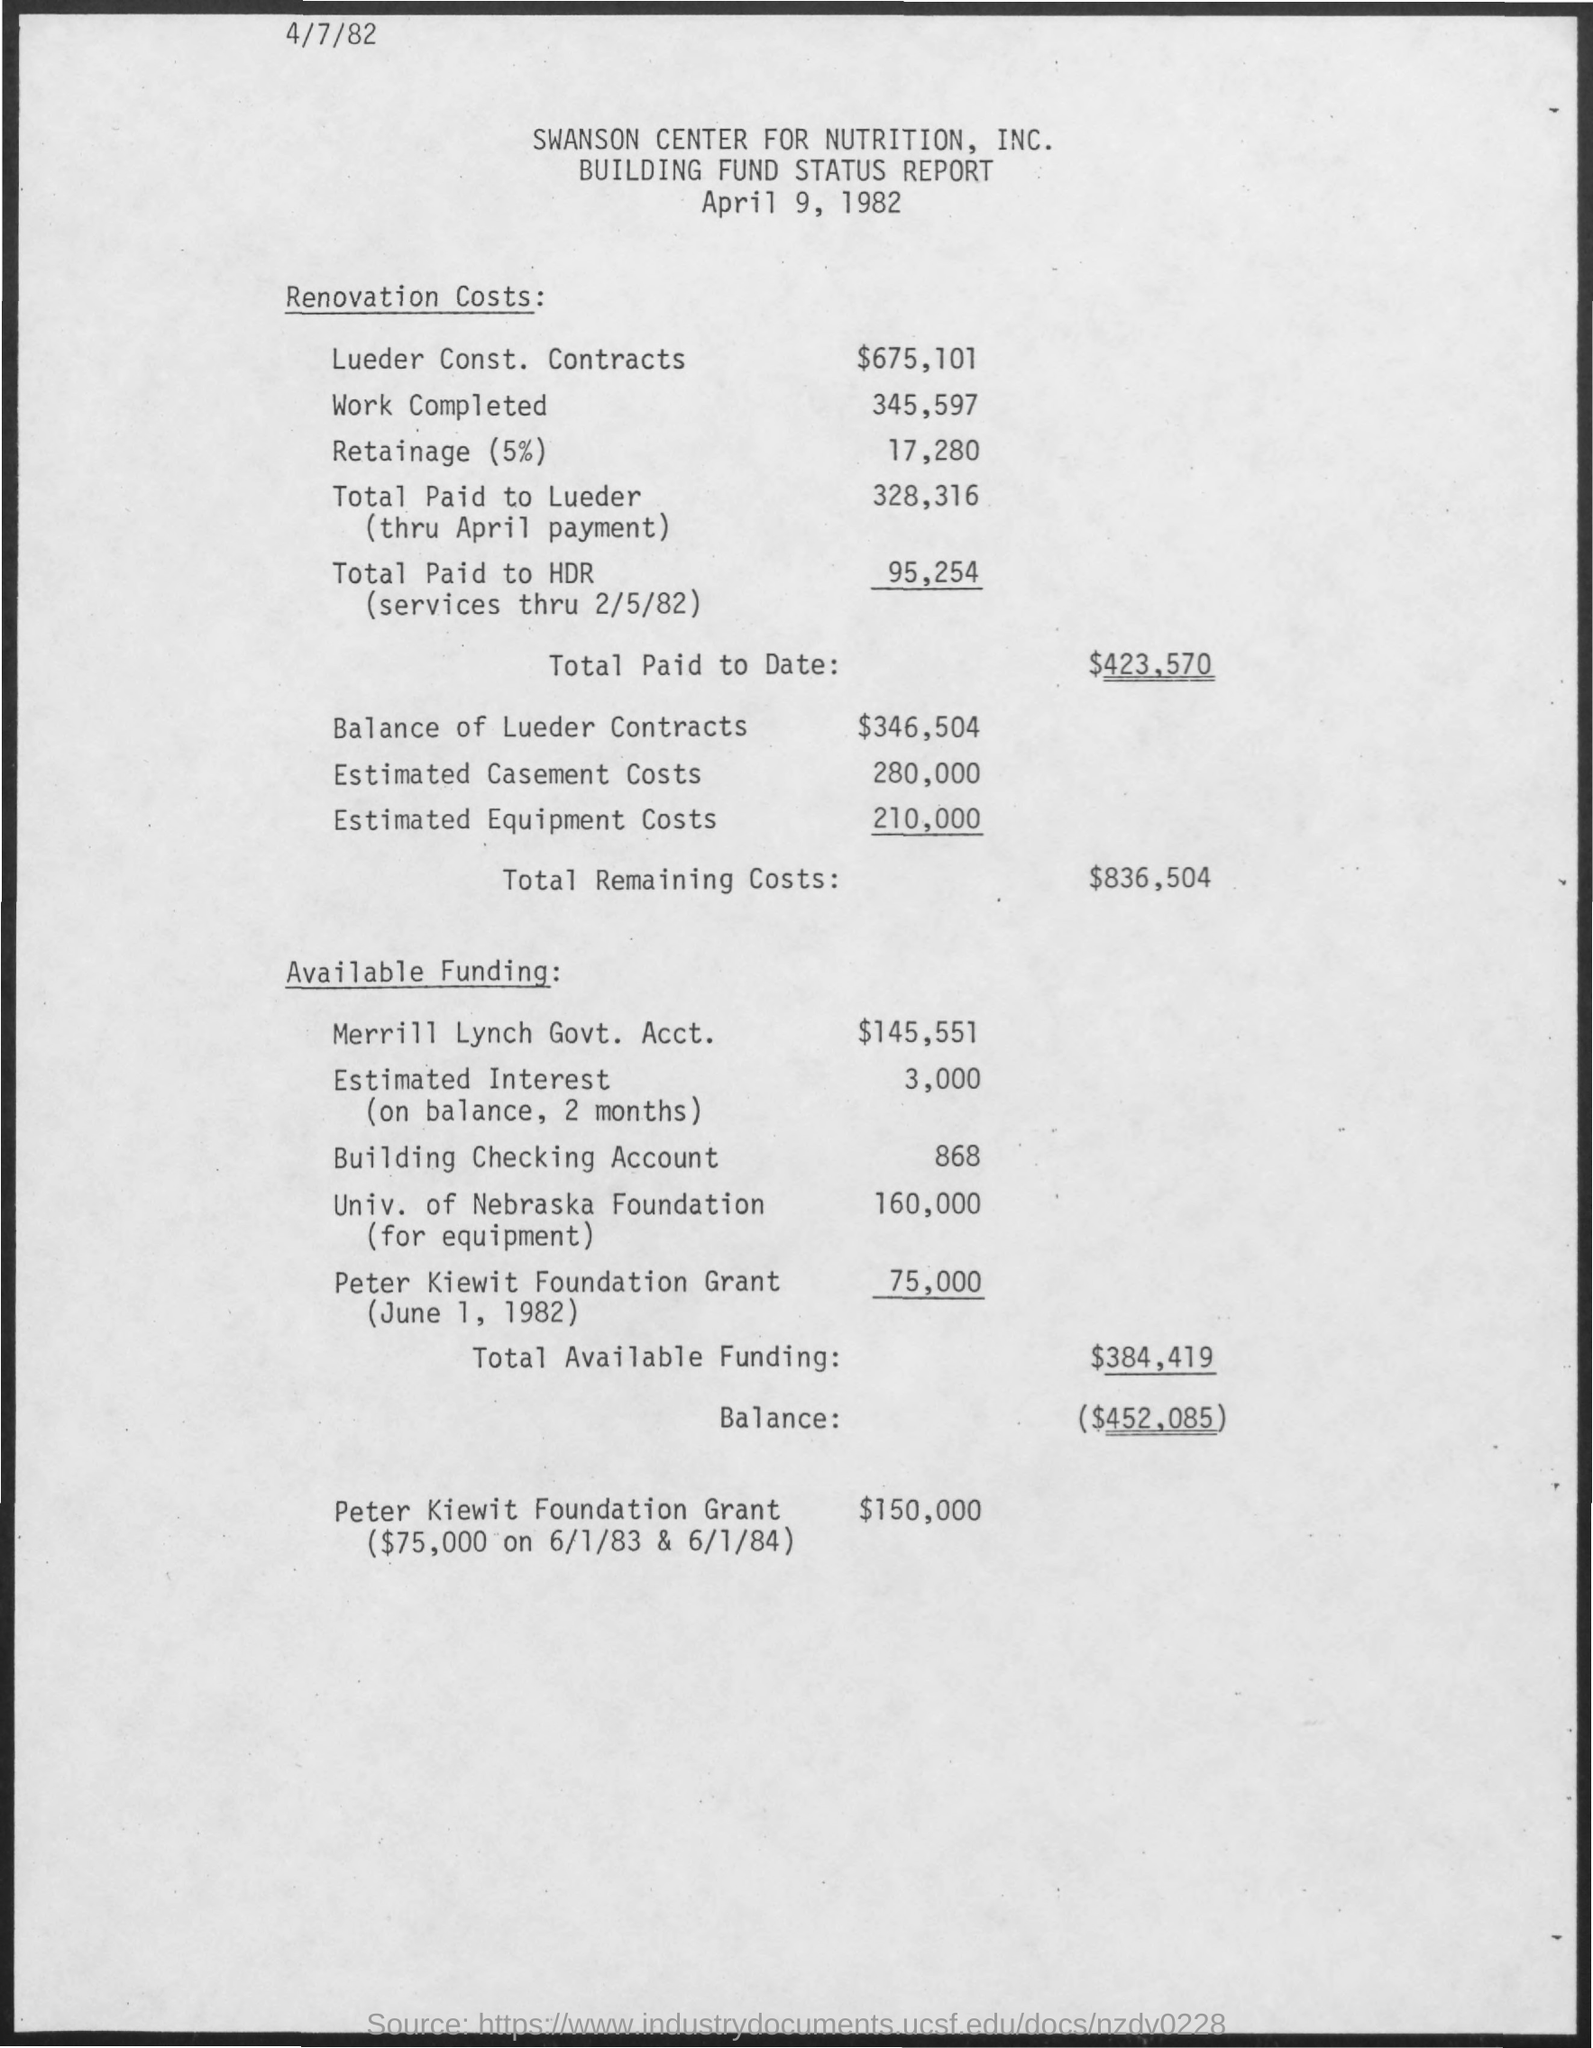List a handful of essential elements in this visual. The estimated equipment costs are 210,000. The estimated cost for the casement is approximately 280,000. 